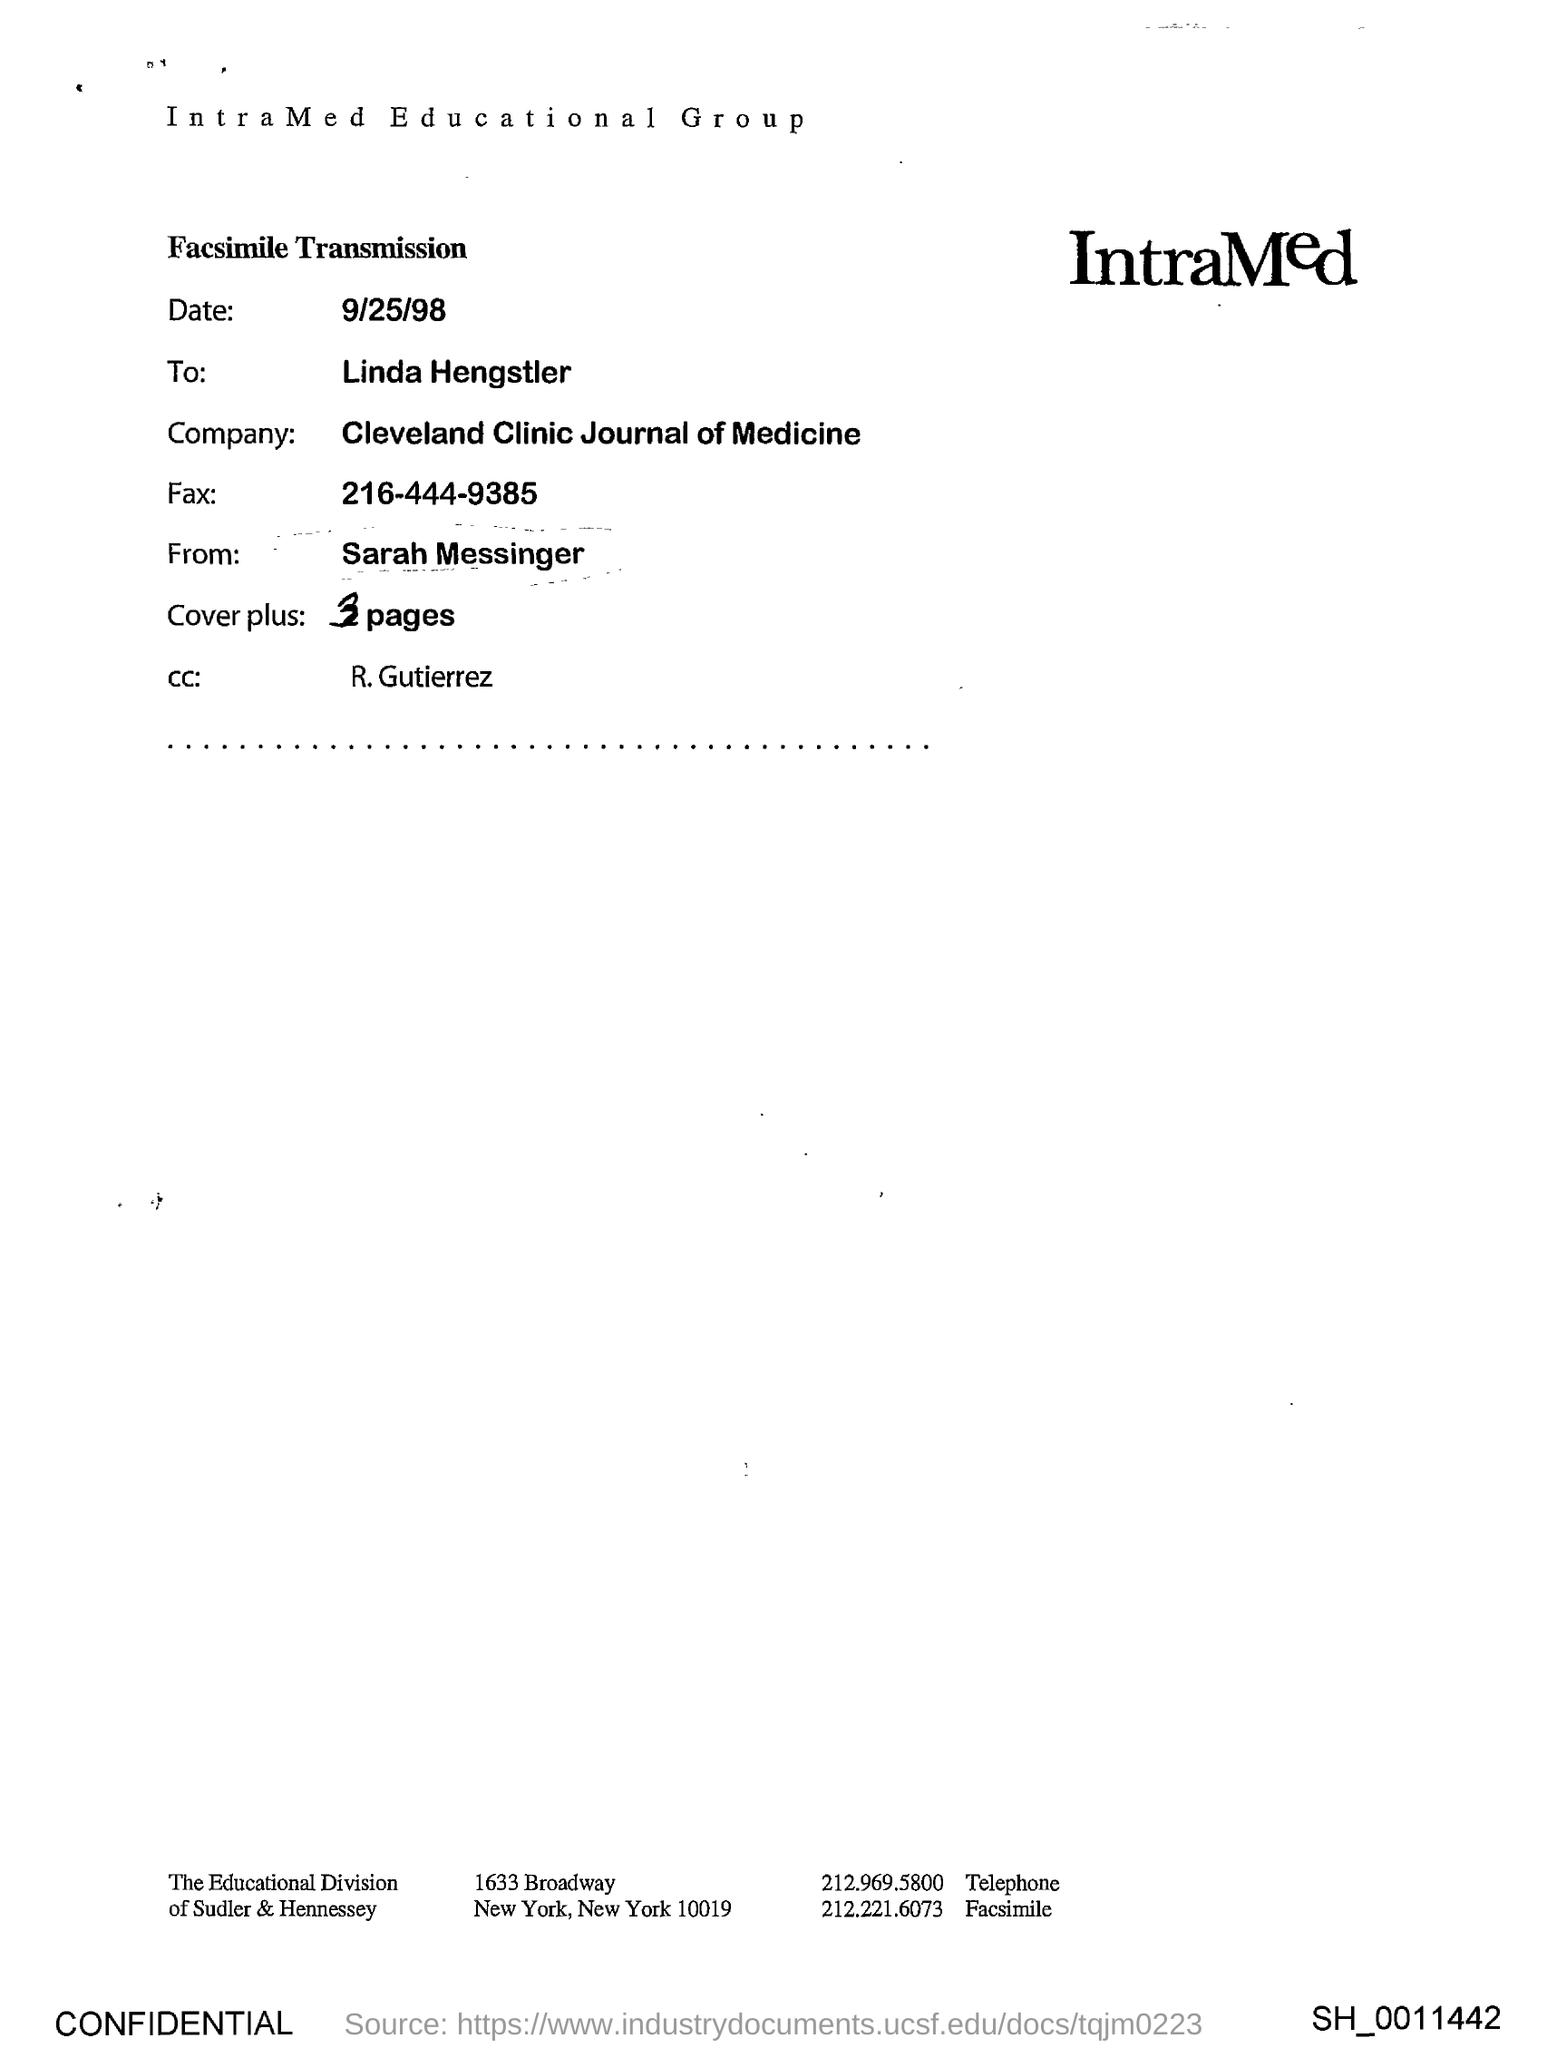Identify some key points in this picture. The Cleveland Clinic Journal of Medicine is mentioned in the document. The individual listed as "R. Gutierrez" is included in the CC. The date is September 25, 1998. 